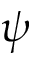<formula> <loc_0><loc_0><loc_500><loc_500>\psi</formula> 